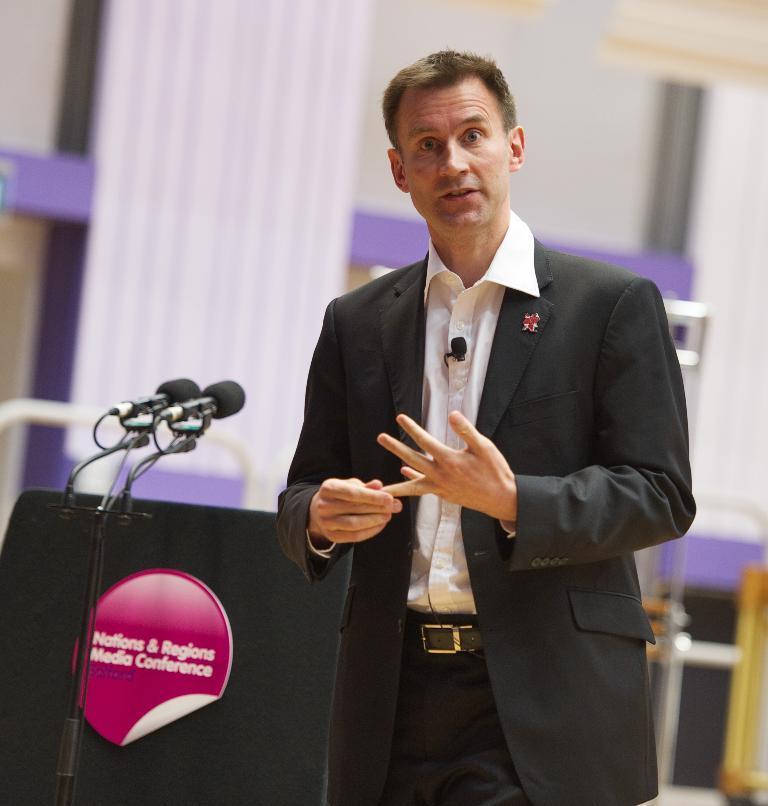In one or two sentences, can you explain what this image depicts? In this picture there is a man standing and talking and there are microphones and there is a sticker on the object and there is text on the sticker. At the back there is a curtain and there are objects. 